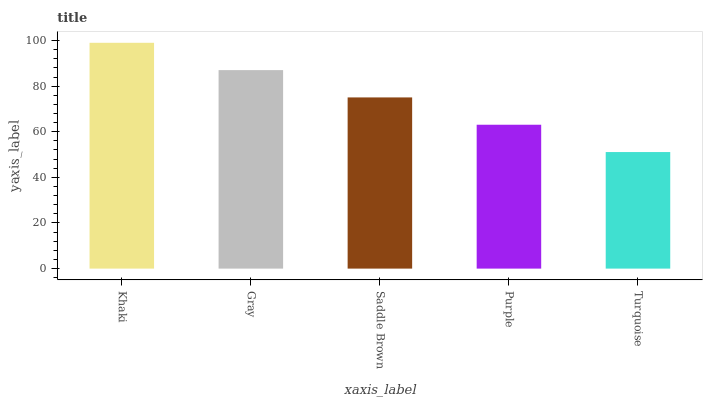Is Turquoise the minimum?
Answer yes or no. Yes. Is Khaki the maximum?
Answer yes or no. Yes. Is Gray the minimum?
Answer yes or no. No. Is Gray the maximum?
Answer yes or no. No. Is Khaki greater than Gray?
Answer yes or no. Yes. Is Gray less than Khaki?
Answer yes or no. Yes. Is Gray greater than Khaki?
Answer yes or no. No. Is Khaki less than Gray?
Answer yes or no. No. Is Saddle Brown the high median?
Answer yes or no. Yes. Is Saddle Brown the low median?
Answer yes or no. Yes. Is Gray the high median?
Answer yes or no. No. Is Turquoise the low median?
Answer yes or no. No. 